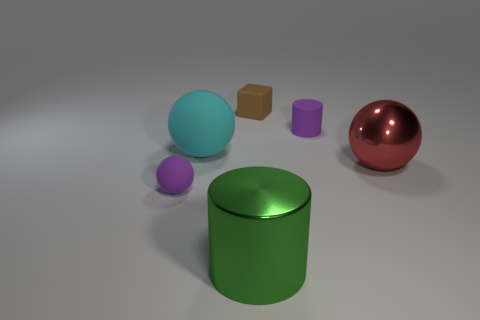Could you speculate on the purpose of these objects being grouped together? It appears to be a collection of objects possibly used for a visual exercise or a test of materials in a virtual environment, showcasing how different textures and shapes respond to light. Do these objects have any real-world applications? While these specific objects may be for display, they can represent items like children's toys, decorative elements, or industrial components, each with uses based on their shapes and materials in various real-world contexts. 